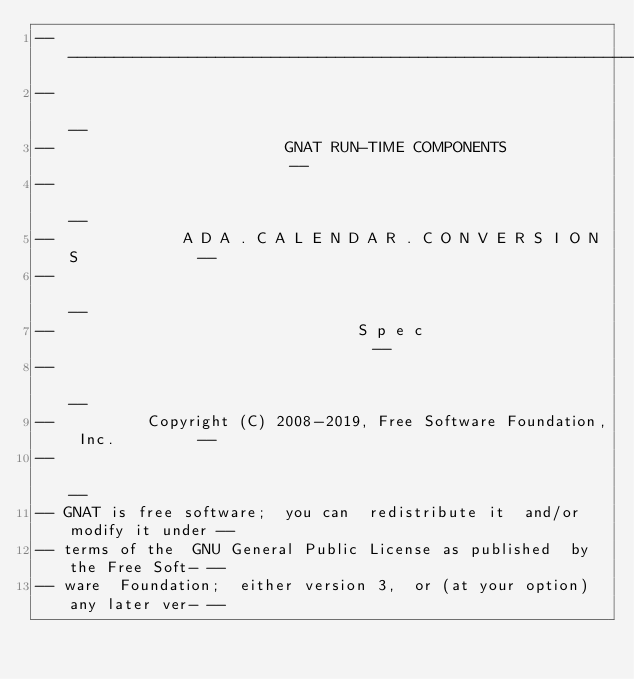Convert code to text. <code><loc_0><loc_0><loc_500><loc_500><_Ada_>------------------------------------------------------------------------------
--                                                                          --
--                         GNAT RUN-TIME COMPONENTS                         --
--                                                                          --
--              A D A . C A L E N D A R . C O N V E R S I O N S             --
--                                                                          --
--                                 S p e c                                  --
--                                                                          --
--          Copyright (C) 2008-2019, Free Software Foundation, Inc.         --
--                                                                          --
-- GNAT is free software;  you can  redistribute it  and/or modify it under --
-- terms of the  GNU General Public License as published  by the Free Soft- --
-- ware  Foundation;  either version 3,  or (at your option) any later ver- --</code> 